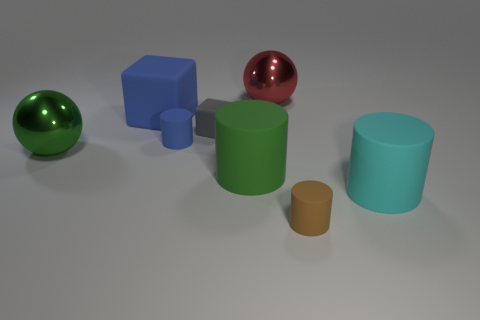Add 1 red cylinders. How many objects exist? 9 Subtract all balls. How many objects are left? 6 Subtract all large metal spheres. Subtract all blue things. How many objects are left? 4 Add 7 small blue cylinders. How many small blue cylinders are left? 8 Add 2 matte blocks. How many matte blocks exist? 4 Subtract 1 blue cylinders. How many objects are left? 7 